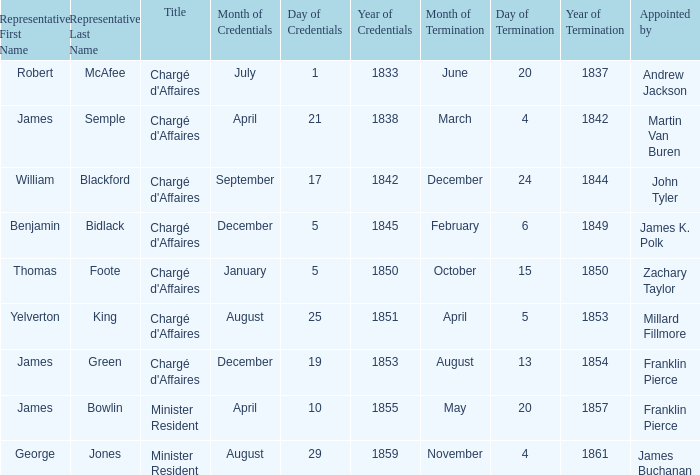What Representative has a Presentation of Credentails of April 10, 1855? James B. Bowlin. 